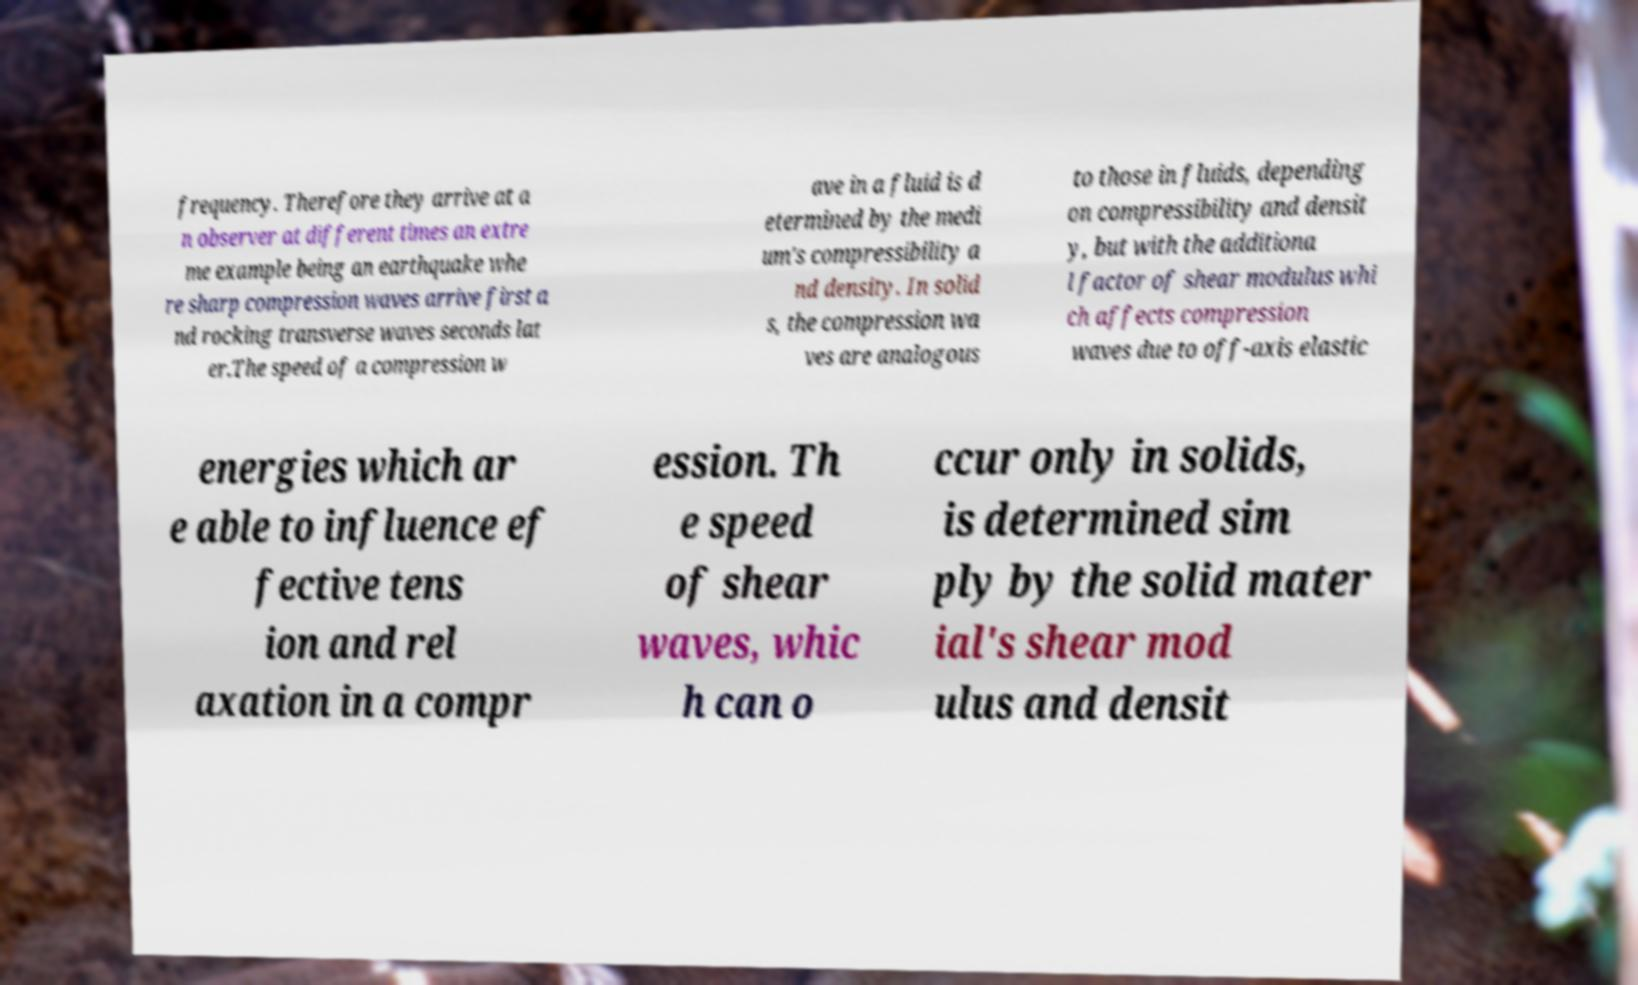There's text embedded in this image that I need extracted. Can you transcribe it verbatim? frequency. Therefore they arrive at a n observer at different times an extre me example being an earthquake whe re sharp compression waves arrive first a nd rocking transverse waves seconds lat er.The speed of a compression w ave in a fluid is d etermined by the medi um's compressibility a nd density. In solid s, the compression wa ves are analogous to those in fluids, depending on compressibility and densit y, but with the additiona l factor of shear modulus whi ch affects compression waves due to off-axis elastic energies which ar e able to influence ef fective tens ion and rel axation in a compr ession. Th e speed of shear waves, whic h can o ccur only in solids, is determined sim ply by the solid mater ial's shear mod ulus and densit 